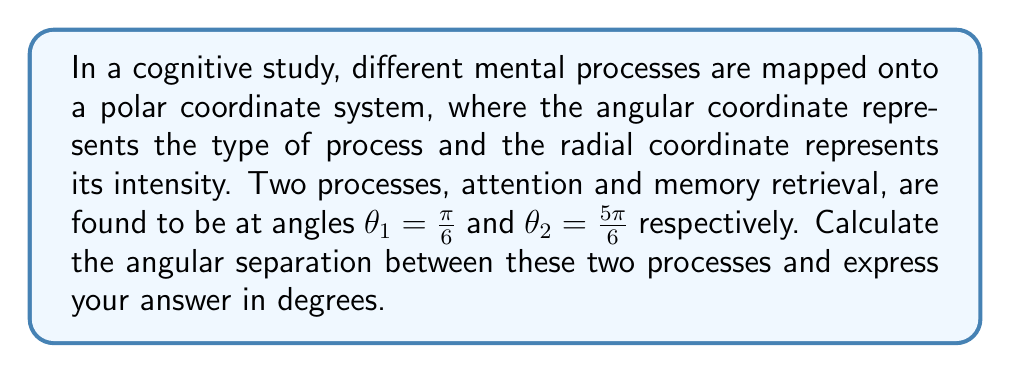Help me with this question. To solve this problem, we need to follow these steps:

1) First, recall that the angular separation between two angles in polar coordinates is given by the absolute difference between the angles:

   $\Delta \theta = |\theta_2 - \theta_1|$

2) We are given:
   $\theta_1 = \frac{\pi}{6}$
   $\theta_2 = \frac{5\pi}{6}$

3) Let's substitute these into our formula:

   $\Delta \theta = |\frac{5\pi}{6} - \frac{\pi}{6}|$

4) Simplify:
   $\Delta \theta = |\frac{4\pi}{6}| = \frac{2\pi}{3}$

5) Now, we need to convert this to degrees. Recall that $\pi$ radians = 180°, so we can set up the following proportion:

   $\frac{2\pi}{3} \text{ radians} = x°$
   $\pi \text{ radians} = 180°$

6) Cross multiply:
   $180 \cdot \frac{2\pi}{3} = \pi x$

7) Simplify:
   $120 = x$

Therefore, the angular separation between the two processes is 120°.
Answer: 120° 